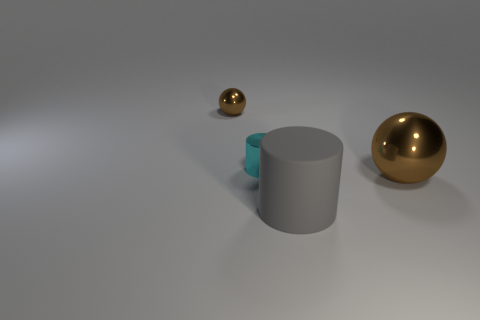The object that is behind the gray rubber object and on the right side of the tiny cyan thing is what color?
Ensure brevity in your answer.  Brown. Is the size of the brown sphere in front of the tiny ball the same as the cylinder that is in front of the small cyan object?
Offer a very short reply. Yes. How many metallic things are the same color as the large metal sphere?
Keep it short and to the point. 1. How many small objects are either cyan metallic cylinders or brown shiny things?
Give a very brief answer. 2. Does the brown ball that is on the left side of the big matte object have the same material as the big brown sphere?
Ensure brevity in your answer.  Yes. What is the color of the small metallic thing that is to the right of the tiny metal ball?
Your answer should be compact. Cyan. Is there a green sphere of the same size as the cyan cylinder?
Provide a succinct answer. No. There is a metallic cylinder; does it have the same size as the brown object left of the cyan thing?
Make the answer very short. Yes. What is the material of the brown thing to the left of the gray cylinder?
Your answer should be very brief. Metal. Are there an equal number of large brown balls that are on the left side of the small ball and small yellow cylinders?
Give a very brief answer. Yes. 